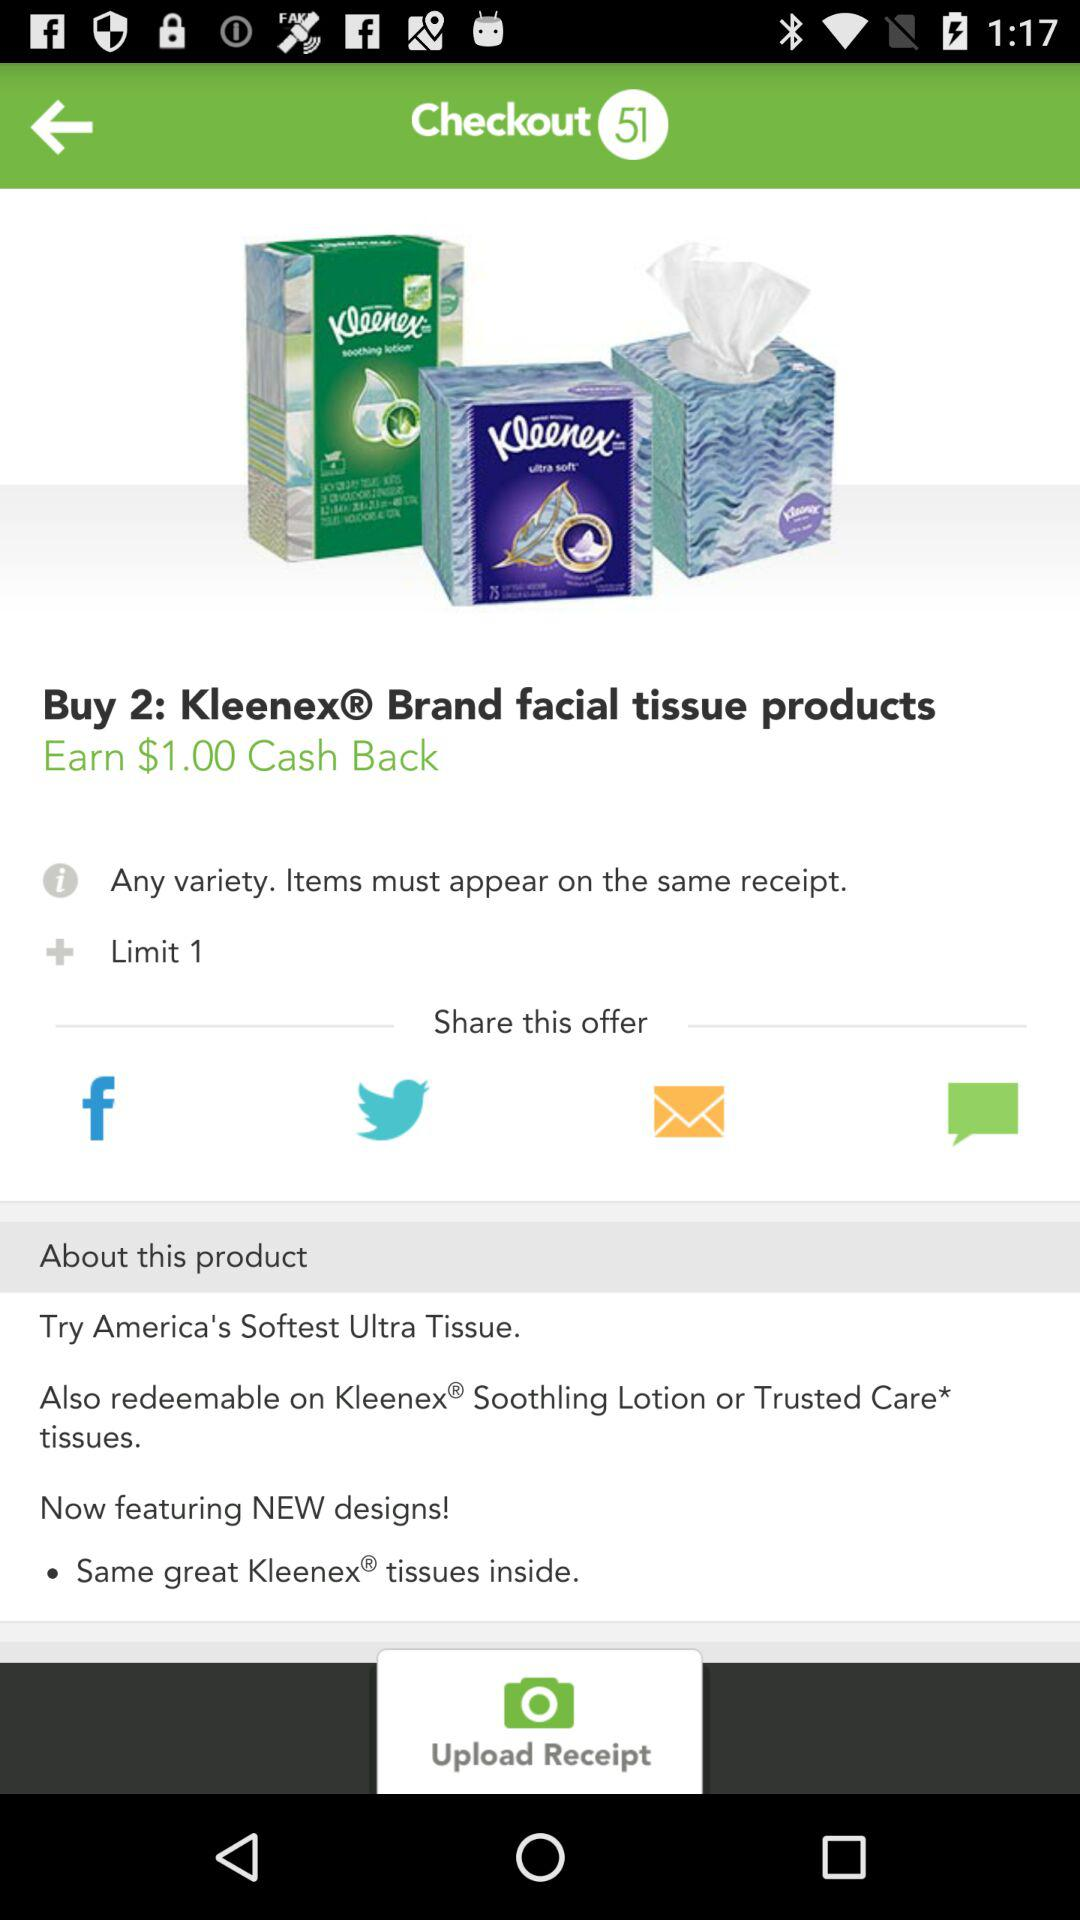How many items must appear on the same receipt to earn the $1.00 cash back?
Answer the question using a single word or phrase. 2 